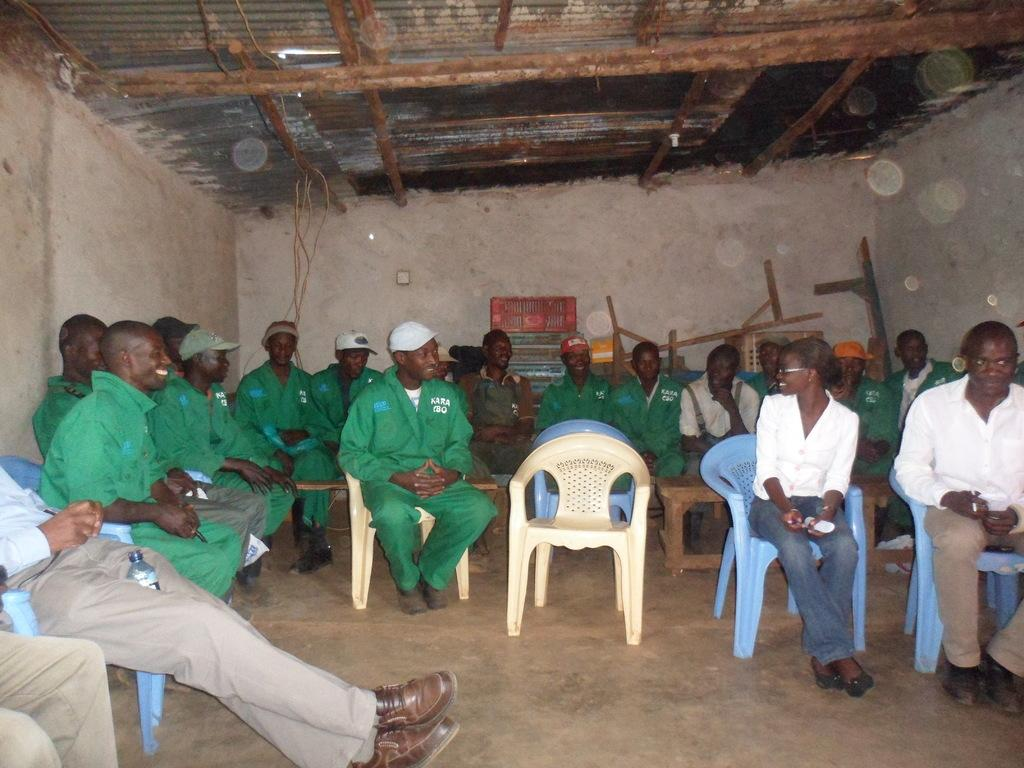How many people are in the image? There is a group of persons in the image. What are the persons in the image doing? The persons are sitting on chairs. What can be seen in the background of the image? There is a wall and a roof in the image. Reasoning: Let's think step by step by step in order to produce the conversation. We start by identifying the main subject in the image, which is the group of persons. Then, we describe what they are doing, which is sitting on chairs. Finally, we mention the background elements, which are the wall and the roof. Each question is designed to elicit a specific detail about the image that is known from the provided facts. Absurd Question/Answer: What type of structure can be seen in the image? There is no specific structure mentioned in the provided facts. However, the presence of a wall and a roof suggests that the image might be of a room or an enclosed space. Can you tell me how many cattle are present in the image? There is no mention of cattle in the provided facts, so it cannot be determined if any are present in the image. What type of action can be seen the cattle performing in the image? There is no mention of cattle in the provided facts, so it cannot be determined if any are present in the image, and therefore, no action can be observed. 